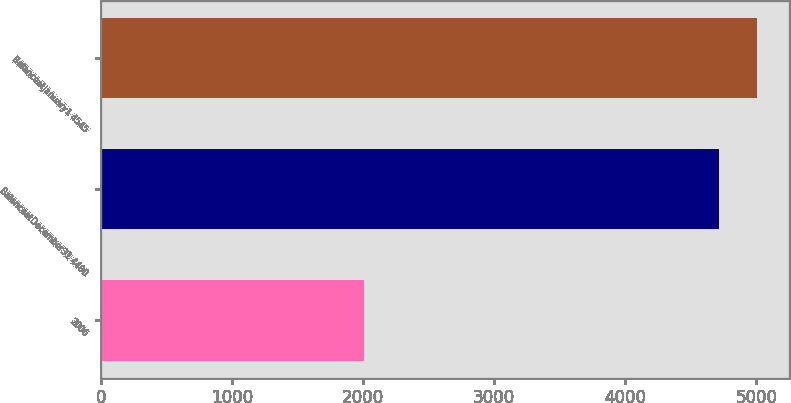Convert chart to OTSL. <chart><loc_0><loc_0><loc_500><loc_500><bar_chart><fcel>2006<fcel>BalanceatDecember31 4480<fcel>BalanceatJanuary1 4545<nl><fcel>2004<fcel>4712<fcel>5002.3<nl></chart> 